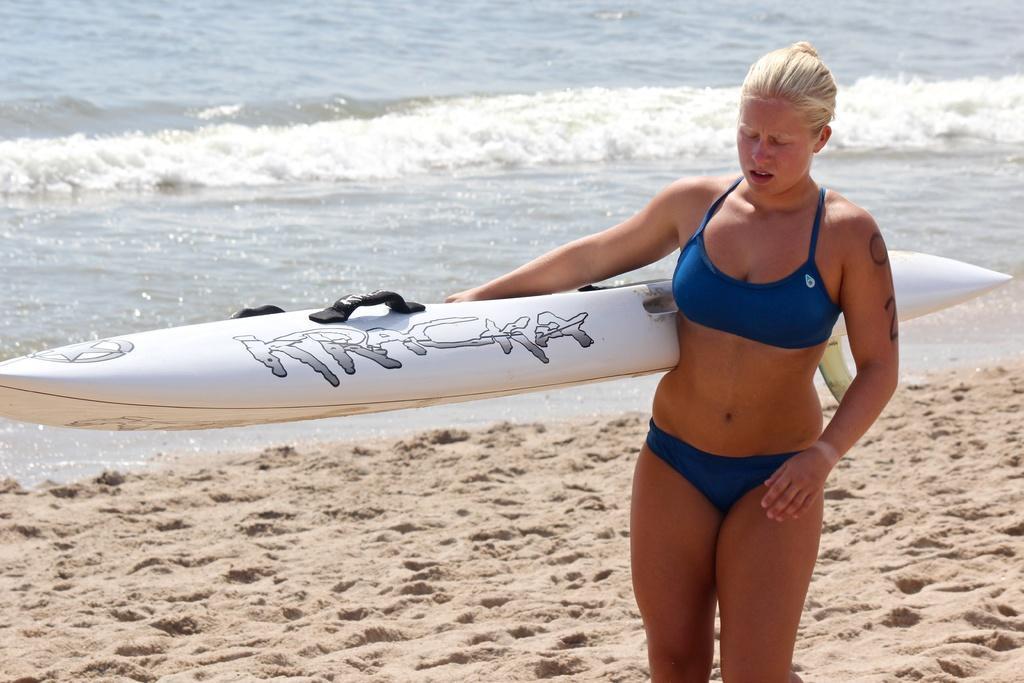Could you give a brief overview of what you see in this image? In the image there is a woman. Who is holding surfboard and walking on sand. In background there is a sea with water. 